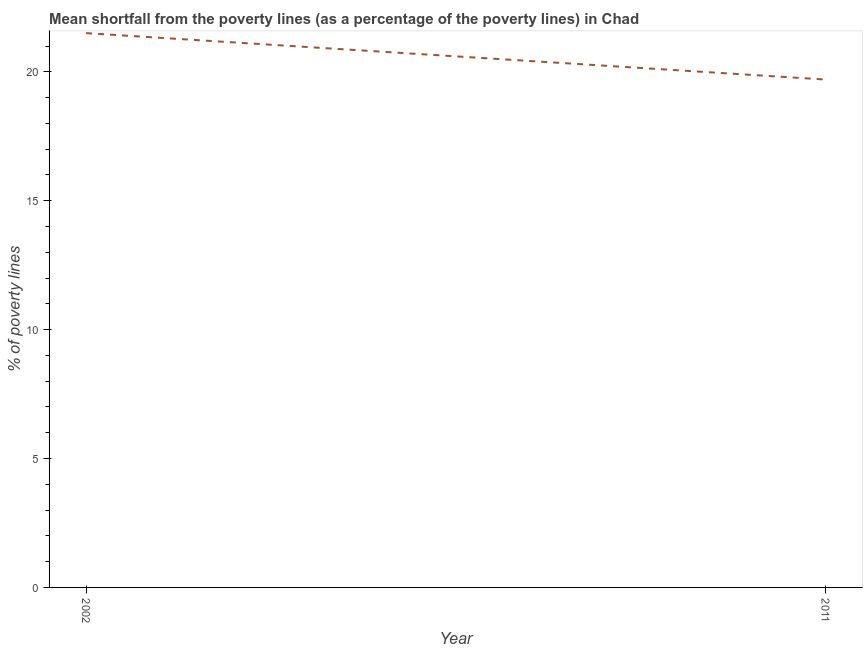What is the poverty gap at national poverty lines in 2011?
Provide a succinct answer. 19.7. Across all years, what is the maximum poverty gap at national poverty lines?
Make the answer very short. 21.5. Across all years, what is the minimum poverty gap at national poverty lines?
Your answer should be compact. 19.7. In which year was the poverty gap at national poverty lines maximum?
Offer a very short reply. 2002. What is the sum of the poverty gap at national poverty lines?
Ensure brevity in your answer.  41.2. What is the difference between the poverty gap at national poverty lines in 2002 and 2011?
Offer a very short reply. 1.8. What is the average poverty gap at national poverty lines per year?
Your response must be concise. 20.6. What is the median poverty gap at national poverty lines?
Your answer should be very brief. 20.6. In how many years, is the poverty gap at national poverty lines greater than 4 %?
Offer a very short reply. 2. Do a majority of the years between 2011 and 2002 (inclusive) have poverty gap at national poverty lines greater than 20 %?
Keep it short and to the point. No. What is the ratio of the poverty gap at national poverty lines in 2002 to that in 2011?
Provide a short and direct response. 1.09. In how many years, is the poverty gap at national poverty lines greater than the average poverty gap at national poverty lines taken over all years?
Ensure brevity in your answer.  1. Does the poverty gap at national poverty lines monotonically increase over the years?
Provide a succinct answer. No. How many lines are there?
Offer a very short reply. 1. What is the difference between two consecutive major ticks on the Y-axis?
Offer a terse response. 5. Does the graph contain any zero values?
Your response must be concise. No. What is the title of the graph?
Provide a succinct answer. Mean shortfall from the poverty lines (as a percentage of the poverty lines) in Chad. What is the label or title of the X-axis?
Keep it short and to the point. Year. What is the label or title of the Y-axis?
Ensure brevity in your answer.  % of poverty lines. What is the % of poverty lines of 2002?
Make the answer very short. 21.5. What is the % of poverty lines of 2011?
Keep it short and to the point. 19.7. What is the difference between the % of poverty lines in 2002 and 2011?
Give a very brief answer. 1.8. What is the ratio of the % of poverty lines in 2002 to that in 2011?
Your response must be concise. 1.09. 